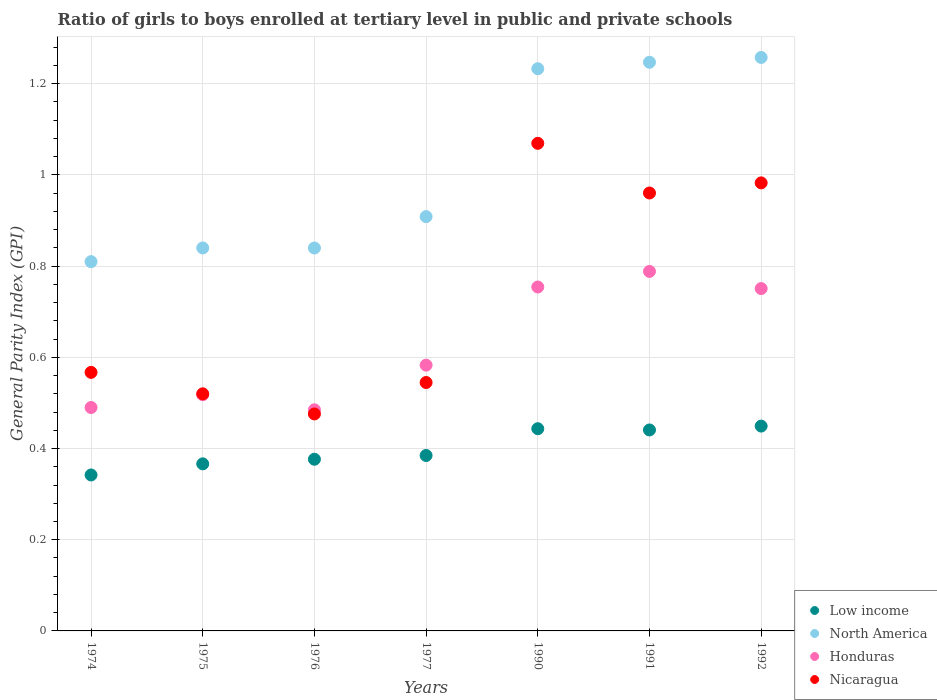How many different coloured dotlines are there?
Make the answer very short. 4. What is the general parity index in Honduras in 1974?
Provide a short and direct response. 0.49. Across all years, what is the maximum general parity index in Honduras?
Provide a succinct answer. 0.79. Across all years, what is the minimum general parity index in Low income?
Keep it short and to the point. 0.34. In which year was the general parity index in Low income minimum?
Your answer should be very brief. 1974. What is the total general parity index in North America in the graph?
Make the answer very short. 7.14. What is the difference between the general parity index in North America in 1974 and that in 1977?
Offer a very short reply. -0.1. What is the difference between the general parity index in Honduras in 1975 and the general parity index in Low income in 1990?
Ensure brevity in your answer.  0.07. What is the average general parity index in North America per year?
Keep it short and to the point. 1.02. In the year 1974, what is the difference between the general parity index in Low income and general parity index in Honduras?
Offer a very short reply. -0.15. In how many years, is the general parity index in Low income greater than 0.88?
Your answer should be very brief. 0. What is the ratio of the general parity index in Low income in 1974 to that in 1990?
Your response must be concise. 0.77. What is the difference between the highest and the second highest general parity index in Honduras?
Make the answer very short. 0.03. What is the difference between the highest and the lowest general parity index in North America?
Your answer should be compact. 0.45. Is it the case that in every year, the sum of the general parity index in Honduras and general parity index in Nicaragua  is greater than the sum of general parity index in North America and general parity index in Low income?
Offer a very short reply. No. Does the general parity index in Honduras monotonically increase over the years?
Offer a very short reply. No. Is the general parity index in Honduras strictly less than the general parity index in Low income over the years?
Offer a very short reply. No. Are the values on the major ticks of Y-axis written in scientific E-notation?
Your answer should be compact. No. How many legend labels are there?
Offer a terse response. 4. How are the legend labels stacked?
Your answer should be compact. Vertical. What is the title of the graph?
Make the answer very short. Ratio of girls to boys enrolled at tertiary level in public and private schools. What is the label or title of the Y-axis?
Make the answer very short. General Parity Index (GPI). What is the General Parity Index (GPI) of Low income in 1974?
Provide a succinct answer. 0.34. What is the General Parity Index (GPI) of North America in 1974?
Make the answer very short. 0.81. What is the General Parity Index (GPI) in Honduras in 1974?
Make the answer very short. 0.49. What is the General Parity Index (GPI) in Nicaragua in 1974?
Keep it short and to the point. 0.57. What is the General Parity Index (GPI) in Low income in 1975?
Your response must be concise. 0.37. What is the General Parity Index (GPI) of North America in 1975?
Keep it short and to the point. 0.84. What is the General Parity Index (GPI) in Honduras in 1975?
Your answer should be very brief. 0.52. What is the General Parity Index (GPI) of Nicaragua in 1975?
Provide a succinct answer. 0.52. What is the General Parity Index (GPI) of Low income in 1976?
Your answer should be compact. 0.38. What is the General Parity Index (GPI) in North America in 1976?
Offer a terse response. 0.84. What is the General Parity Index (GPI) in Honduras in 1976?
Ensure brevity in your answer.  0.48. What is the General Parity Index (GPI) of Nicaragua in 1976?
Provide a short and direct response. 0.48. What is the General Parity Index (GPI) of Low income in 1977?
Give a very brief answer. 0.38. What is the General Parity Index (GPI) of North America in 1977?
Provide a succinct answer. 0.91. What is the General Parity Index (GPI) of Honduras in 1977?
Your response must be concise. 0.58. What is the General Parity Index (GPI) of Nicaragua in 1977?
Ensure brevity in your answer.  0.54. What is the General Parity Index (GPI) in Low income in 1990?
Make the answer very short. 0.44. What is the General Parity Index (GPI) in North America in 1990?
Your answer should be compact. 1.23. What is the General Parity Index (GPI) of Honduras in 1990?
Your answer should be compact. 0.75. What is the General Parity Index (GPI) in Nicaragua in 1990?
Your response must be concise. 1.07. What is the General Parity Index (GPI) of Low income in 1991?
Keep it short and to the point. 0.44. What is the General Parity Index (GPI) of North America in 1991?
Ensure brevity in your answer.  1.25. What is the General Parity Index (GPI) of Honduras in 1991?
Your answer should be compact. 0.79. What is the General Parity Index (GPI) in Nicaragua in 1991?
Provide a short and direct response. 0.96. What is the General Parity Index (GPI) of Low income in 1992?
Provide a succinct answer. 0.45. What is the General Parity Index (GPI) of North America in 1992?
Keep it short and to the point. 1.26. What is the General Parity Index (GPI) in Honduras in 1992?
Your answer should be compact. 0.75. What is the General Parity Index (GPI) of Nicaragua in 1992?
Ensure brevity in your answer.  0.98. Across all years, what is the maximum General Parity Index (GPI) in Low income?
Your response must be concise. 0.45. Across all years, what is the maximum General Parity Index (GPI) of North America?
Keep it short and to the point. 1.26. Across all years, what is the maximum General Parity Index (GPI) in Honduras?
Give a very brief answer. 0.79. Across all years, what is the maximum General Parity Index (GPI) in Nicaragua?
Keep it short and to the point. 1.07. Across all years, what is the minimum General Parity Index (GPI) in Low income?
Make the answer very short. 0.34. Across all years, what is the minimum General Parity Index (GPI) of North America?
Your response must be concise. 0.81. Across all years, what is the minimum General Parity Index (GPI) in Honduras?
Offer a terse response. 0.48. Across all years, what is the minimum General Parity Index (GPI) in Nicaragua?
Give a very brief answer. 0.48. What is the total General Parity Index (GPI) in Low income in the graph?
Provide a succinct answer. 2.8. What is the total General Parity Index (GPI) of North America in the graph?
Offer a terse response. 7.14. What is the total General Parity Index (GPI) in Honduras in the graph?
Your response must be concise. 4.37. What is the total General Parity Index (GPI) of Nicaragua in the graph?
Give a very brief answer. 5.12. What is the difference between the General Parity Index (GPI) of Low income in 1974 and that in 1975?
Offer a very short reply. -0.02. What is the difference between the General Parity Index (GPI) of North America in 1974 and that in 1975?
Make the answer very short. -0.03. What is the difference between the General Parity Index (GPI) in Honduras in 1974 and that in 1975?
Your response must be concise. -0.03. What is the difference between the General Parity Index (GPI) in Nicaragua in 1974 and that in 1975?
Offer a very short reply. 0.05. What is the difference between the General Parity Index (GPI) of Low income in 1974 and that in 1976?
Provide a short and direct response. -0.03. What is the difference between the General Parity Index (GPI) in North America in 1974 and that in 1976?
Offer a terse response. -0.03. What is the difference between the General Parity Index (GPI) of Honduras in 1974 and that in 1976?
Keep it short and to the point. 0.01. What is the difference between the General Parity Index (GPI) of Nicaragua in 1974 and that in 1976?
Offer a terse response. 0.09. What is the difference between the General Parity Index (GPI) of Low income in 1974 and that in 1977?
Give a very brief answer. -0.04. What is the difference between the General Parity Index (GPI) in North America in 1974 and that in 1977?
Provide a short and direct response. -0.1. What is the difference between the General Parity Index (GPI) of Honduras in 1974 and that in 1977?
Your response must be concise. -0.09. What is the difference between the General Parity Index (GPI) of Nicaragua in 1974 and that in 1977?
Your response must be concise. 0.02. What is the difference between the General Parity Index (GPI) in Low income in 1974 and that in 1990?
Offer a very short reply. -0.1. What is the difference between the General Parity Index (GPI) in North America in 1974 and that in 1990?
Make the answer very short. -0.42. What is the difference between the General Parity Index (GPI) of Honduras in 1974 and that in 1990?
Your answer should be very brief. -0.26. What is the difference between the General Parity Index (GPI) of Nicaragua in 1974 and that in 1990?
Offer a very short reply. -0.5. What is the difference between the General Parity Index (GPI) in Low income in 1974 and that in 1991?
Your answer should be compact. -0.1. What is the difference between the General Parity Index (GPI) in North America in 1974 and that in 1991?
Your response must be concise. -0.44. What is the difference between the General Parity Index (GPI) in Honduras in 1974 and that in 1991?
Your answer should be very brief. -0.3. What is the difference between the General Parity Index (GPI) in Nicaragua in 1974 and that in 1991?
Your answer should be very brief. -0.39. What is the difference between the General Parity Index (GPI) of Low income in 1974 and that in 1992?
Your answer should be compact. -0.11. What is the difference between the General Parity Index (GPI) of North America in 1974 and that in 1992?
Your response must be concise. -0.45. What is the difference between the General Parity Index (GPI) in Honduras in 1974 and that in 1992?
Offer a terse response. -0.26. What is the difference between the General Parity Index (GPI) of Nicaragua in 1974 and that in 1992?
Your response must be concise. -0.42. What is the difference between the General Parity Index (GPI) of Low income in 1975 and that in 1976?
Your response must be concise. -0.01. What is the difference between the General Parity Index (GPI) of Honduras in 1975 and that in 1976?
Keep it short and to the point. 0.03. What is the difference between the General Parity Index (GPI) of Nicaragua in 1975 and that in 1976?
Offer a very short reply. 0.04. What is the difference between the General Parity Index (GPI) of Low income in 1975 and that in 1977?
Your answer should be very brief. -0.02. What is the difference between the General Parity Index (GPI) of North America in 1975 and that in 1977?
Your answer should be compact. -0.07. What is the difference between the General Parity Index (GPI) of Honduras in 1975 and that in 1977?
Offer a terse response. -0.06. What is the difference between the General Parity Index (GPI) of Nicaragua in 1975 and that in 1977?
Provide a short and direct response. -0.02. What is the difference between the General Parity Index (GPI) of Low income in 1975 and that in 1990?
Provide a short and direct response. -0.08. What is the difference between the General Parity Index (GPI) in North America in 1975 and that in 1990?
Make the answer very short. -0.39. What is the difference between the General Parity Index (GPI) in Honduras in 1975 and that in 1990?
Keep it short and to the point. -0.24. What is the difference between the General Parity Index (GPI) of Nicaragua in 1975 and that in 1990?
Offer a very short reply. -0.55. What is the difference between the General Parity Index (GPI) of Low income in 1975 and that in 1991?
Give a very brief answer. -0.07. What is the difference between the General Parity Index (GPI) in North America in 1975 and that in 1991?
Your response must be concise. -0.41. What is the difference between the General Parity Index (GPI) in Honduras in 1975 and that in 1991?
Give a very brief answer. -0.27. What is the difference between the General Parity Index (GPI) of Nicaragua in 1975 and that in 1991?
Provide a succinct answer. -0.44. What is the difference between the General Parity Index (GPI) in Low income in 1975 and that in 1992?
Your response must be concise. -0.08. What is the difference between the General Parity Index (GPI) in North America in 1975 and that in 1992?
Offer a terse response. -0.42. What is the difference between the General Parity Index (GPI) in Honduras in 1975 and that in 1992?
Provide a short and direct response. -0.23. What is the difference between the General Parity Index (GPI) of Nicaragua in 1975 and that in 1992?
Give a very brief answer. -0.46. What is the difference between the General Parity Index (GPI) of Low income in 1976 and that in 1977?
Keep it short and to the point. -0.01. What is the difference between the General Parity Index (GPI) of North America in 1976 and that in 1977?
Keep it short and to the point. -0.07. What is the difference between the General Parity Index (GPI) of Honduras in 1976 and that in 1977?
Make the answer very short. -0.1. What is the difference between the General Parity Index (GPI) of Nicaragua in 1976 and that in 1977?
Offer a terse response. -0.07. What is the difference between the General Parity Index (GPI) in Low income in 1976 and that in 1990?
Make the answer very short. -0.07. What is the difference between the General Parity Index (GPI) in North America in 1976 and that in 1990?
Ensure brevity in your answer.  -0.39. What is the difference between the General Parity Index (GPI) in Honduras in 1976 and that in 1990?
Offer a very short reply. -0.27. What is the difference between the General Parity Index (GPI) in Nicaragua in 1976 and that in 1990?
Offer a terse response. -0.59. What is the difference between the General Parity Index (GPI) in Low income in 1976 and that in 1991?
Ensure brevity in your answer.  -0.06. What is the difference between the General Parity Index (GPI) of North America in 1976 and that in 1991?
Make the answer very short. -0.41. What is the difference between the General Parity Index (GPI) in Honduras in 1976 and that in 1991?
Offer a very short reply. -0.3. What is the difference between the General Parity Index (GPI) of Nicaragua in 1976 and that in 1991?
Ensure brevity in your answer.  -0.48. What is the difference between the General Parity Index (GPI) in Low income in 1976 and that in 1992?
Keep it short and to the point. -0.07. What is the difference between the General Parity Index (GPI) in North America in 1976 and that in 1992?
Offer a very short reply. -0.42. What is the difference between the General Parity Index (GPI) in Honduras in 1976 and that in 1992?
Give a very brief answer. -0.27. What is the difference between the General Parity Index (GPI) in Nicaragua in 1976 and that in 1992?
Your answer should be compact. -0.51. What is the difference between the General Parity Index (GPI) of Low income in 1977 and that in 1990?
Offer a very short reply. -0.06. What is the difference between the General Parity Index (GPI) of North America in 1977 and that in 1990?
Your response must be concise. -0.32. What is the difference between the General Parity Index (GPI) in Honduras in 1977 and that in 1990?
Your response must be concise. -0.17. What is the difference between the General Parity Index (GPI) of Nicaragua in 1977 and that in 1990?
Keep it short and to the point. -0.52. What is the difference between the General Parity Index (GPI) of Low income in 1977 and that in 1991?
Your answer should be very brief. -0.06. What is the difference between the General Parity Index (GPI) of North America in 1977 and that in 1991?
Your answer should be compact. -0.34. What is the difference between the General Parity Index (GPI) of Honduras in 1977 and that in 1991?
Keep it short and to the point. -0.21. What is the difference between the General Parity Index (GPI) in Nicaragua in 1977 and that in 1991?
Keep it short and to the point. -0.42. What is the difference between the General Parity Index (GPI) in Low income in 1977 and that in 1992?
Ensure brevity in your answer.  -0.06. What is the difference between the General Parity Index (GPI) in North America in 1977 and that in 1992?
Make the answer very short. -0.35. What is the difference between the General Parity Index (GPI) in Honduras in 1977 and that in 1992?
Ensure brevity in your answer.  -0.17. What is the difference between the General Parity Index (GPI) of Nicaragua in 1977 and that in 1992?
Ensure brevity in your answer.  -0.44. What is the difference between the General Parity Index (GPI) in Low income in 1990 and that in 1991?
Ensure brevity in your answer.  0. What is the difference between the General Parity Index (GPI) of North America in 1990 and that in 1991?
Offer a very short reply. -0.01. What is the difference between the General Parity Index (GPI) of Honduras in 1990 and that in 1991?
Your response must be concise. -0.03. What is the difference between the General Parity Index (GPI) in Nicaragua in 1990 and that in 1991?
Ensure brevity in your answer.  0.11. What is the difference between the General Parity Index (GPI) of Low income in 1990 and that in 1992?
Your answer should be compact. -0.01. What is the difference between the General Parity Index (GPI) in North America in 1990 and that in 1992?
Your answer should be compact. -0.02. What is the difference between the General Parity Index (GPI) of Honduras in 1990 and that in 1992?
Your answer should be compact. 0. What is the difference between the General Parity Index (GPI) in Nicaragua in 1990 and that in 1992?
Give a very brief answer. 0.09. What is the difference between the General Parity Index (GPI) in Low income in 1991 and that in 1992?
Your answer should be very brief. -0.01. What is the difference between the General Parity Index (GPI) in North America in 1991 and that in 1992?
Keep it short and to the point. -0.01. What is the difference between the General Parity Index (GPI) of Honduras in 1991 and that in 1992?
Offer a very short reply. 0.04. What is the difference between the General Parity Index (GPI) in Nicaragua in 1991 and that in 1992?
Your answer should be compact. -0.02. What is the difference between the General Parity Index (GPI) in Low income in 1974 and the General Parity Index (GPI) in North America in 1975?
Your answer should be very brief. -0.5. What is the difference between the General Parity Index (GPI) in Low income in 1974 and the General Parity Index (GPI) in Honduras in 1975?
Your answer should be compact. -0.18. What is the difference between the General Parity Index (GPI) in Low income in 1974 and the General Parity Index (GPI) in Nicaragua in 1975?
Offer a terse response. -0.18. What is the difference between the General Parity Index (GPI) in North America in 1974 and the General Parity Index (GPI) in Honduras in 1975?
Provide a short and direct response. 0.29. What is the difference between the General Parity Index (GPI) of North America in 1974 and the General Parity Index (GPI) of Nicaragua in 1975?
Your response must be concise. 0.29. What is the difference between the General Parity Index (GPI) in Honduras in 1974 and the General Parity Index (GPI) in Nicaragua in 1975?
Provide a short and direct response. -0.03. What is the difference between the General Parity Index (GPI) in Low income in 1974 and the General Parity Index (GPI) in North America in 1976?
Offer a very short reply. -0.5. What is the difference between the General Parity Index (GPI) of Low income in 1974 and the General Parity Index (GPI) of Honduras in 1976?
Provide a succinct answer. -0.14. What is the difference between the General Parity Index (GPI) in Low income in 1974 and the General Parity Index (GPI) in Nicaragua in 1976?
Give a very brief answer. -0.13. What is the difference between the General Parity Index (GPI) of North America in 1974 and the General Parity Index (GPI) of Honduras in 1976?
Offer a terse response. 0.32. What is the difference between the General Parity Index (GPI) of North America in 1974 and the General Parity Index (GPI) of Nicaragua in 1976?
Keep it short and to the point. 0.33. What is the difference between the General Parity Index (GPI) in Honduras in 1974 and the General Parity Index (GPI) in Nicaragua in 1976?
Provide a short and direct response. 0.01. What is the difference between the General Parity Index (GPI) in Low income in 1974 and the General Parity Index (GPI) in North America in 1977?
Make the answer very short. -0.57. What is the difference between the General Parity Index (GPI) of Low income in 1974 and the General Parity Index (GPI) of Honduras in 1977?
Provide a short and direct response. -0.24. What is the difference between the General Parity Index (GPI) in Low income in 1974 and the General Parity Index (GPI) in Nicaragua in 1977?
Your answer should be very brief. -0.2. What is the difference between the General Parity Index (GPI) of North America in 1974 and the General Parity Index (GPI) of Honduras in 1977?
Keep it short and to the point. 0.23. What is the difference between the General Parity Index (GPI) in North America in 1974 and the General Parity Index (GPI) in Nicaragua in 1977?
Ensure brevity in your answer.  0.27. What is the difference between the General Parity Index (GPI) of Honduras in 1974 and the General Parity Index (GPI) of Nicaragua in 1977?
Ensure brevity in your answer.  -0.05. What is the difference between the General Parity Index (GPI) in Low income in 1974 and the General Parity Index (GPI) in North America in 1990?
Provide a short and direct response. -0.89. What is the difference between the General Parity Index (GPI) of Low income in 1974 and the General Parity Index (GPI) of Honduras in 1990?
Provide a succinct answer. -0.41. What is the difference between the General Parity Index (GPI) in Low income in 1974 and the General Parity Index (GPI) in Nicaragua in 1990?
Make the answer very short. -0.73. What is the difference between the General Parity Index (GPI) of North America in 1974 and the General Parity Index (GPI) of Honduras in 1990?
Keep it short and to the point. 0.06. What is the difference between the General Parity Index (GPI) in North America in 1974 and the General Parity Index (GPI) in Nicaragua in 1990?
Make the answer very short. -0.26. What is the difference between the General Parity Index (GPI) in Honduras in 1974 and the General Parity Index (GPI) in Nicaragua in 1990?
Offer a very short reply. -0.58. What is the difference between the General Parity Index (GPI) of Low income in 1974 and the General Parity Index (GPI) of North America in 1991?
Provide a succinct answer. -0.91. What is the difference between the General Parity Index (GPI) in Low income in 1974 and the General Parity Index (GPI) in Honduras in 1991?
Your answer should be very brief. -0.45. What is the difference between the General Parity Index (GPI) in Low income in 1974 and the General Parity Index (GPI) in Nicaragua in 1991?
Your answer should be very brief. -0.62. What is the difference between the General Parity Index (GPI) in North America in 1974 and the General Parity Index (GPI) in Honduras in 1991?
Provide a short and direct response. 0.02. What is the difference between the General Parity Index (GPI) of North America in 1974 and the General Parity Index (GPI) of Nicaragua in 1991?
Offer a very short reply. -0.15. What is the difference between the General Parity Index (GPI) of Honduras in 1974 and the General Parity Index (GPI) of Nicaragua in 1991?
Offer a terse response. -0.47. What is the difference between the General Parity Index (GPI) of Low income in 1974 and the General Parity Index (GPI) of North America in 1992?
Give a very brief answer. -0.92. What is the difference between the General Parity Index (GPI) in Low income in 1974 and the General Parity Index (GPI) in Honduras in 1992?
Offer a terse response. -0.41. What is the difference between the General Parity Index (GPI) of Low income in 1974 and the General Parity Index (GPI) of Nicaragua in 1992?
Provide a short and direct response. -0.64. What is the difference between the General Parity Index (GPI) of North America in 1974 and the General Parity Index (GPI) of Honduras in 1992?
Your response must be concise. 0.06. What is the difference between the General Parity Index (GPI) of North America in 1974 and the General Parity Index (GPI) of Nicaragua in 1992?
Ensure brevity in your answer.  -0.17. What is the difference between the General Parity Index (GPI) of Honduras in 1974 and the General Parity Index (GPI) of Nicaragua in 1992?
Your answer should be compact. -0.49. What is the difference between the General Parity Index (GPI) of Low income in 1975 and the General Parity Index (GPI) of North America in 1976?
Your response must be concise. -0.47. What is the difference between the General Parity Index (GPI) of Low income in 1975 and the General Parity Index (GPI) of Honduras in 1976?
Offer a very short reply. -0.12. What is the difference between the General Parity Index (GPI) of Low income in 1975 and the General Parity Index (GPI) of Nicaragua in 1976?
Your answer should be compact. -0.11. What is the difference between the General Parity Index (GPI) in North America in 1975 and the General Parity Index (GPI) in Honduras in 1976?
Keep it short and to the point. 0.35. What is the difference between the General Parity Index (GPI) of North America in 1975 and the General Parity Index (GPI) of Nicaragua in 1976?
Give a very brief answer. 0.36. What is the difference between the General Parity Index (GPI) of Honduras in 1975 and the General Parity Index (GPI) of Nicaragua in 1976?
Your answer should be compact. 0.04. What is the difference between the General Parity Index (GPI) of Low income in 1975 and the General Parity Index (GPI) of North America in 1977?
Your answer should be compact. -0.54. What is the difference between the General Parity Index (GPI) in Low income in 1975 and the General Parity Index (GPI) in Honduras in 1977?
Offer a very short reply. -0.22. What is the difference between the General Parity Index (GPI) in Low income in 1975 and the General Parity Index (GPI) in Nicaragua in 1977?
Provide a succinct answer. -0.18. What is the difference between the General Parity Index (GPI) in North America in 1975 and the General Parity Index (GPI) in Honduras in 1977?
Give a very brief answer. 0.26. What is the difference between the General Parity Index (GPI) of North America in 1975 and the General Parity Index (GPI) of Nicaragua in 1977?
Make the answer very short. 0.3. What is the difference between the General Parity Index (GPI) in Honduras in 1975 and the General Parity Index (GPI) in Nicaragua in 1977?
Offer a terse response. -0.03. What is the difference between the General Parity Index (GPI) in Low income in 1975 and the General Parity Index (GPI) in North America in 1990?
Make the answer very short. -0.87. What is the difference between the General Parity Index (GPI) in Low income in 1975 and the General Parity Index (GPI) in Honduras in 1990?
Make the answer very short. -0.39. What is the difference between the General Parity Index (GPI) in Low income in 1975 and the General Parity Index (GPI) in Nicaragua in 1990?
Give a very brief answer. -0.7. What is the difference between the General Parity Index (GPI) in North America in 1975 and the General Parity Index (GPI) in Honduras in 1990?
Offer a very short reply. 0.09. What is the difference between the General Parity Index (GPI) in North America in 1975 and the General Parity Index (GPI) in Nicaragua in 1990?
Ensure brevity in your answer.  -0.23. What is the difference between the General Parity Index (GPI) in Honduras in 1975 and the General Parity Index (GPI) in Nicaragua in 1990?
Your response must be concise. -0.55. What is the difference between the General Parity Index (GPI) of Low income in 1975 and the General Parity Index (GPI) of North America in 1991?
Your response must be concise. -0.88. What is the difference between the General Parity Index (GPI) of Low income in 1975 and the General Parity Index (GPI) of Honduras in 1991?
Offer a terse response. -0.42. What is the difference between the General Parity Index (GPI) in Low income in 1975 and the General Parity Index (GPI) in Nicaragua in 1991?
Offer a terse response. -0.59. What is the difference between the General Parity Index (GPI) in North America in 1975 and the General Parity Index (GPI) in Honduras in 1991?
Offer a very short reply. 0.05. What is the difference between the General Parity Index (GPI) of North America in 1975 and the General Parity Index (GPI) of Nicaragua in 1991?
Offer a terse response. -0.12. What is the difference between the General Parity Index (GPI) in Honduras in 1975 and the General Parity Index (GPI) in Nicaragua in 1991?
Offer a terse response. -0.44. What is the difference between the General Parity Index (GPI) of Low income in 1975 and the General Parity Index (GPI) of North America in 1992?
Give a very brief answer. -0.89. What is the difference between the General Parity Index (GPI) of Low income in 1975 and the General Parity Index (GPI) of Honduras in 1992?
Provide a short and direct response. -0.38. What is the difference between the General Parity Index (GPI) in Low income in 1975 and the General Parity Index (GPI) in Nicaragua in 1992?
Your response must be concise. -0.62. What is the difference between the General Parity Index (GPI) in North America in 1975 and the General Parity Index (GPI) in Honduras in 1992?
Keep it short and to the point. 0.09. What is the difference between the General Parity Index (GPI) of North America in 1975 and the General Parity Index (GPI) of Nicaragua in 1992?
Ensure brevity in your answer.  -0.14. What is the difference between the General Parity Index (GPI) of Honduras in 1975 and the General Parity Index (GPI) of Nicaragua in 1992?
Your answer should be very brief. -0.46. What is the difference between the General Parity Index (GPI) in Low income in 1976 and the General Parity Index (GPI) in North America in 1977?
Offer a terse response. -0.53. What is the difference between the General Parity Index (GPI) of Low income in 1976 and the General Parity Index (GPI) of Honduras in 1977?
Make the answer very short. -0.21. What is the difference between the General Parity Index (GPI) in Low income in 1976 and the General Parity Index (GPI) in Nicaragua in 1977?
Offer a terse response. -0.17. What is the difference between the General Parity Index (GPI) in North America in 1976 and the General Parity Index (GPI) in Honduras in 1977?
Provide a succinct answer. 0.26. What is the difference between the General Parity Index (GPI) in North America in 1976 and the General Parity Index (GPI) in Nicaragua in 1977?
Keep it short and to the point. 0.29. What is the difference between the General Parity Index (GPI) in Honduras in 1976 and the General Parity Index (GPI) in Nicaragua in 1977?
Keep it short and to the point. -0.06. What is the difference between the General Parity Index (GPI) in Low income in 1976 and the General Parity Index (GPI) in North America in 1990?
Ensure brevity in your answer.  -0.86. What is the difference between the General Parity Index (GPI) in Low income in 1976 and the General Parity Index (GPI) in Honduras in 1990?
Your answer should be very brief. -0.38. What is the difference between the General Parity Index (GPI) of Low income in 1976 and the General Parity Index (GPI) of Nicaragua in 1990?
Your answer should be compact. -0.69. What is the difference between the General Parity Index (GPI) in North America in 1976 and the General Parity Index (GPI) in Honduras in 1990?
Keep it short and to the point. 0.09. What is the difference between the General Parity Index (GPI) of North America in 1976 and the General Parity Index (GPI) of Nicaragua in 1990?
Offer a very short reply. -0.23. What is the difference between the General Parity Index (GPI) of Honduras in 1976 and the General Parity Index (GPI) of Nicaragua in 1990?
Ensure brevity in your answer.  -0.58. What is the difference between the General Parity Index (GPI) of Low income in 1976 and the General Parity Index (GPI) of North America in 1991?
Provide a succinct answer. -0.87. What is the difference between the General Parity Index (GPI) of Low income in 1976 and the General Parity Index (GPI) of Honduras in 1991?
Provide a short and direct response. -0.41. What is the difference between the General Parity Index (GPI) of Low income in 1976 and the General Parity Index (GPI) of Nicaragua in 1991?
Provide a short and direct response. -0.58. What is the difference between the General Parity Index (GPI) in North America in 1976 and the General Parity Index (GPI) in Honduras in 1991?
Make the answer very short. 0.05. What is the difference between the General Parity Index (GPI) in North America in 1976 and the General Parity Index (GPI) in Nicaragua in 1991?
Ensure brevity in your answer.  -0.12. What is the difference between the General Parity Index (GPI) in Honduras in 1976 and the General Parity Index (GPI) in Nicaragua in 1991?
Make the answer very short. -0.48. What is the difference between the General Parity Index (GPI) of Low income in 1976 and the General Parity Index (GPI) of North America in 1992?
Keep it short and to the point. -0.88. What is the difference between the General Parity Index (GPI) of Low income in 1976 and the General Parity Index (GPI) of Honduras in 1992?
Make the answer very short. -0.37. What is the difference between the General Parity Index (GPI) of Low income in 1976 and the General Parity Index (GPI) of Nicaragua in 1992?
Ensure brevity in your answer.  -0.61. What is the difference between the General Parity Index (GPI) in North America in 1976 and the General Parity Index (GPI) in Honduras in 1992?
Offer a very short reply. 0.09. What is the difference between the General Parity Index (GPI) of North America in 1976 and the General Parity Index (GPI) of Nicaragua in 1992?
Your answer should be compact. -0.14. What is the difference between the General Parity Index (GPI) in Honduras in 1976 and the General Parity Index (GPI) in Nicaragua in 1992?
Provide a succinct answer. -0.5. What is the difference between the General Parity Index (GPI) in Low income in 1977 and the General Parity Index (GPI) in North America in 1990?
Ensure brevity in your answer.  -0.85. What is the difference between the General Parity Index (GPI) of Low income in 1977 and the General Parity Index (GPI) of Honduras in 1990?
Ensure brevity in your answer.  -0.37. What is the difference between the General Parity Index (GPI) in Low income in 1977 and the General Parity Index (GPI) in Nicaragua in 1990?
Offer a very short reply. -0.68. What is the difference between the General Parity Index (GPI) of North America in 1977 and the General Parity Index (GPI) of Honduras in 1990?
Offer a very short reply. 0.15. What is the difference between the General Parity Index (GPI) of North America in 1977 and the General Parity Index (GPI) of Nicaragua in 1990?
Keep it short and to the point. -0.16. What is the difference between the General Parity Index (GPI) of Honduras in 1977 and the General Parity Index (GPI) of Nicaragua in 1990?
Give a very brief answer. -0.49. What is the difference between the General Parity Index (GPI) in Low income in 1977 and the General Parity Index (GPI) in North America in 1991?
Offer a terse response. -0.86. What is the difference between the General Parity Index (GPI) of Low income in 1977 and the General Parity Index (GPI) of Honduras in 1991?
Offer a very short reply. -0.4. What is the difference between the General Parity Index (GPI) of Low income in 1977 and the General Parity Index (GPI) of Nicaragua in 1991?
Provide a succinct answer. -0.58. What is the difference between the General Parity Index (GPI) in North America in 1977 and the General Parity Index (GPI) in Honduras in 1991?
Keep it short and to the point. 0.12. What is the difference between the General Parity Index (GPI) of North America in 1977 and the General Parity Index (GPI) of Nicaragua in 1991?
Provide a succinct answer. -0.05. What is the difference between the General Parity Index (GPI) of Honduras in 1977 and the General Parity Index (GPI) of Nicaragua in 1991?
Your answer should be very brief. -0.38. What is the difference between the General Parity Index (GPI) in Low income in 1977 and the General Parity Index (GPI) in North America in 1992?
Offer a very short reply. -0.87. What is the difference between the General Parity Index (GPI) of Low income in 1977 and the General Parity Index (GPI) of Honduras in 1992?
Ensure brevity in your answer.  -0.37. What is the difference between the General Parity Index (GPI) of Low income in 1977 and the General Parity Index (GPI) of Nicaragua in 1992?
Your answer should be very brief. -0.6. What is the difference between the General Parity Index (GPI) of North America in 1977 and the General Parity Index (GPI) of Honduras in 1992?
Your response must be concise. 0.16. What is the difference between the General Parity Index (GPI) in North America in 1977 and the General Parity Index (GPI) in Nicaragua in 1992?
Give a very brief answer. -0.07. What is the difference between the General Parity Index (GPI) of Honduras in 1977 and the General Parity Index (GPI) of Nicaragua in 1992?
Provide a short and direct response. -0.4. What is the difference between the General Parity Index (GPI) of Low income in 1990 and the General Parity Index (GPI) of North America in 1991?
Your answer should be compact. -0.8. What is the difference between the General Parity Index (GPI) of Low income in 1990 and the General Parity Index (GPI) of Honduras in 1991?
Your answer should be very brief. -0.34. What is the difference between the General Parity Index (GPI) of Low income in 1990 and the General Parity Index (GPI) of Nicaragua in 1991?
Provide a short and direct response. -0.52. What is the difference between the General Parity Index (GPI) of North America in 1990 and the General Parity Index (GPI) of Honduras in 1991?
Provide a short and direct response. 0.44. What is the difference between the General Parity Index (GPI) of North America in 1990 and the General Parity Index (GPI) of Nicaragua in 1991?
Give a very brief answer. 0.27. What is the difference between the General Parity Index (GPI) of Honduras in 1990 and the General Parity Index (GPI) of Nicaragua in 1991?
Keep it short and to the point. -0.21. What is the difference between the General Parity Index (GPI) in Low income in 1990 and the General Parity Index (GPI) in North America in 1992?
Give a very brief answer. -0.81. What is the difference between the General Parity Index (GPI) of Low income in 1990 and the General Parity Index (GPI) of Honduras in 1992?
Ensure brevity in your answer.  -0.31. What is the difference between the General Parity Index (GPI) of Low income in 1990 and the General Parity Index (GPI) of Nicaragua in 1992?
Keep it short and to the point. -0.54. What is the difference between the General Parity Index (GPI) in North America in 1990 and the General Parity Index (GPI) in Honduras in 1992?
Provide a succinct answer. 0.48. What is the difference between the General Parity Index (GPI) of North America in 1990 and the General Parity Index (GPI) of Nicaragua in 1992?
Your answer should be compact. 0.25. What is the difference between the General Parity Index (GPI) of Honduras in 1990 and the General Parity Index (GPI) of Nicaragua in 1992?
Your answer should be very brief. -0.23. What is the difference between the General Parity Index (GPI) in Low income in 1991 and the General Parity Index (GPI) in North America in 1992?
Make the answer very short. -0.82. What is the difference between the General Parity Index (GPI) of Low income in 1991 and the General Parity Index (GPI) of Honduras in 1992?
Provide a succinct answer. -0.31. What is the difference between the General Parity Index (GPI) of Low income in 1991 and the General Parity Index (GPI) of Nicaragua in 1992?
Your response must be concise. -0.54. What is the difference between the General Parity Index (GPI) of North America in 1991 and the General Parity Index (GPI) of Honduras in 1992?
Ensure brevity in your answer.  0.5. What is the difference between the General Parity Index (GPI) in North America in 1991 and the General Parity Index (GPI) in Nicaragua in 1992?
Make the answer very short. 0.26. What is the difference between the General Parity Index (GPI) of Honduras in 1991 and the General Parity Index (GPI) of Nicaragua in 1992?
Make the answer very short. -0.19. What is the average General Parity Index (GPI) in Low income per year?
Provide a succinct answer. 0.4. What is the average General Parity Index (GPI) of North America per year?
Ensure brevity in your answer.  1.02. What is the average General Parity Index (GPI) in Honduras per year?
Your response must be concise. 0.62. What is the average General Parity Index (GPI) in Nicaragua per year?
Provide a short and direct response. 0.73. In the year 1974, what is the difference between the General Parity Index (GPI) in Low income and General Parity Index (GPI) in North America?
Offer a terse response. -0.47. In the year 1974, what is the difference between the General Parity Index (GPI) of Low income and General Parity Index (GPI) of Honduras?
Keep it short and to the point. -0.15. In the year 1974, what is the difference between the General Parity Index (GPI) of Low income and General Parity Index (GPI) of Nicaragua?
Make the answer very short. -0.23. In the year 1974, what is the difference between the General Parity Index (GPI) in North America and General Parity Index (GPI) in Honduras?
Keep it short and to the point. 0.32. In the year 1974, what is the difference between the General Parity Index (GPI) of North America and General Parity Index (GPI) of Nicaragua?
Provide a short and direct response. 0.24. In the year 1974, what is the difference between the General Parity Index (GPI) in Honduras and General Parity Index (GPI) in Nicaragua?
Provide a succinct answer. -0.08. In the year 1975, what is the difference between the General Parity Index (GPI) in Low income and General Parity Index (GPI) in North America?
Provide a succinct answer. -0.47. In the year 1975, what is the difference between the General Parity Index (GPI) in Low income and General Parity Index (GPI) in Honduras?
Provide a succinct answer. -0.15. In the year 1975, what is the difference between the General Parity Index (GPI) of Low income and General Parity Index (GPI) of Nicaragua?
Keep it short and to the point. -0.15. In the year 1975, what is the difference between the General Parity Index (GPI) in North America and General Parity Index (GPI) in Honduras?
Your answer should be compact. 0.32. In the year 1975, what is the difference between the General Parity Index (GPI) of North America and General Parity Index (GPI) of Nicaragua?
Ensure brevity in your answer.  0.32. In the year 1975, what is the difference between the General Parity Index (GPI) in Honduras and General Parity Index (GPI) in Nicaragua?
Offer a very short reply. -0. In the year 1976, what is the difference between the General Parity Index (GPI) of Low income and General Parity Index (GPI) of North America?
Your answer should be very brief. -0.46. In the year 1976, what is the difference between the General Parity Index (GPI) of Low income and General Parity Index (GPI) of Honduras?
Keep it short and to the point. -0.11. In the year 1976, what is the difference between the General Parity Index (GPI) of Low income and General Parity Index (GPI) of Nicaragua?
Provide a succinct answer. -0.1. In the year 1976, what is the difference between the General Parity Index (GPI) in North America and General Parity Index (GPI) in Honduras?
Provide a short and direct response. 0.35. In the year 1976, what is the difference between the General Parity Index (GPI) in North America and General Parity Index (GPI) in Nicaragua?
Your response must be concise. 0.36. In the year 1976, what is the difference between the General Parity Index (GPI) of Honduras and General Parity Index (GPI) of Nicaragua?
Offer a very short reply. 0.01. In the year 1977, what is the difference between the General Parity Index (GPI) of Low income and General Parity Index (GPI) of North America?
Offer a very short reply. -0.52. In the year 1977, what is the difference between the General Parity Index (GPI) in Low income and General Parity Index (GPI) in Honduras?
Make the answer very short. -0.2. In the year 1977, what is the difference between the General Parity Index (GPI) in Low income and General Parity Index (GPI) in Nicaragua?
Provide a succinct answer. -0.16. In the year 1977, what is the difference between the General Parity Index (GPI) of North America and General Parity Index (GPI) of Honduras?
Your answer should be compact. 0.33. In the year 1977, what is the difference between the General Parity Index (GPI) in North America and General Parity Index (GPI) in Nicaragua?
Give a very brief answer. 0.36. In the year 1977, what is the difference between the General Parity Index (GPI) in Honduras and General Parity Index (GPI) in Nicaragua?
Offer a terse response. 0.04. In the year 1990, what is the difference between the General Parity Index (GPI) in Low income and General Parity Index (GPI) in North America?
Provide a short and direct response. -0.79. In the year 1990, what is the difference between the General Parity Index (GPI) of Low income and General Parity Index (GPI) of Honduras?
Offer a very short reply. -0.31. In the year 1990, what is the difference between the General Parity Index (GPI) of Low income and General Parity Index (GPI) of Nicaragua?
Offer a terse response. -0.63. In the year 1990, what is the difference between the General Parity Index (GPI) of North America and General Parity Index (GPI) of Honduras?
Your response must be concise. 0.48. In the year 1990, what is the difference between the General Parity Index (GPI) in North America and General Parity Index (GPI) in Nicaragua?
Your response must be concise. 0.16. In the year 1990, what is the difference between the General Parity Index (GPI) of Honduras and General Parity Index (GPI) of Nicaragua?
Offer a terse response. -0.32. In the year 1991, what is the difference between the General Parity Index (GPI) of Low income and General Parity Index (GPI) of North America?
Make the answer very short. -0.81. In the year 1991, what is the difference between the General Parity Index (GPI) of Low income and General Parity Index (GPI) of Honduras?
Your answer should be very brief. -0.35. In the year 1991, what is the difference between the General Parity Index (GPI) of Low income and General Parity Index (GPI) of Nicaragua?
Your response must be concise. -0.52. In the year 1991, what is the difference between the General Parity Index (GPI) of North America and General Parity Index (GPI) of Honduras?
Give a very brief answer. 0.46. In the year 1991, what is the difference between the General Parity Index (GPI) of North America and General Parity Index (GPI) of Nicaragua?
Your answer should be compact. 0.29. In the year 1991, what is the difference between the General Parity Index (GPI) of Honduras and General Parity Index (GPI) of Nicaragua?
Provide a short and direct response. -0.17. In the year 1992, what is the difference between the General Parity Index (GPI) in Low income and General Parity Index (GPI) in North America?
Your response must be concise. -0.81. In the year 1992, what is the difference between the General Parity Index (GPI) of Low income and General Parity Index (GPI) of Honduras?
Your response must be concise. -0.3. In the year 1992, what is the difference between the General Parity Index (GPI) in Low income and General Parity Index (GPI) in Nicaragua?
Offer a terse response. -0.53. In the year 1992, what is the difference between the General Parity Index (GPI) in North America and General Parity Index (GPI) in Honduras?
Provide a succinct answer. 0.51. In the year 1992, what is the difference between the General Parity Index (GPI) of North America and General Parity Index (GPI) of Nicaragua?
Keep it short and to the point. 0.28. In the year 1992, what is the difference between the General Parity Index (GPI) in Honduras and General Parity Index (GPI) in Nicaragua?
Provide a short and direct response. -0.23. What is the ratio of the General Parity Index (GPI) in Low income in 1974 to that in 1975?
Your response must be concise. 0.93. What is the ratio of the General Parity Index (GPI) of North America in 1974 to that in 1975?
Provide a succinct answer. 0.96. What is the ratio of the General Parity Index (GPI) of Honduras in 1974 to that in 1975?
Provide a short and direct response. 0.95. What is the ratio of the General Parity Index (GPI) of Nicaragua in 1974 to that in 1975?
Offer a terse response. 1.09. What is the ratio of the General Parity Index (GPI) of Low income in 1974 to that in 1976?
Offer a very short reply. 0.91. What is the ratio of the General Parity Index (GPI) of North America in 1974 to that in 1976?
Your answer should be compact. 0.96. What is the ratio of the General Parity Index (GPI) of Honduras in 1974 to that in 1976?
Give a very brief answer. 1.01. What is the ratio of the General Parity Index (GPI) in Nicaragua in 1974 to that in 1976?
Ensure brevity in your answer.  1.19. What is the ratio of the General Parity Index (GPI) in Low income in 1974 to that in 1977?
Offer a very short reply. 0.89. What is the ratio of the General Parity Index (GPI) of North America in 1974 to that in 1977?
Give a very brief answer. 0.89. What is the ratio of the General Parity Index (GPI) in Honduras in 1974 to that in 1977?
Keep it short and to the point. 0.84. What is the ratio of the General Parity Index (GPI) in Nicaragua in 1974 to that in 1977?
Make the answer very short. 1.04. What is the ratio of the General Parity Index (GPI) of Low income in 1974 to that in 1990?
Make the answer very short. 0.77. What is the ratio of the General Parity Index (GPI) in North America in 1974 to that in 1990?
Make the answer very short. 0.66. What is the ratio of the General Parity Index (GPI) in Honduras in 1974 to that in 1990?
Offer a terse response. 0.65. What is the ratio of the General Parity Index (GPI) of Nicaragua in 1974 to that in 1990?
Give a very brief answer. 0.53. What is the ratio of the General Parity Index (GPI) in Low income in 1974 to that in 1991?
Offer a very short reply. 0.78. What is the ratio of the General Parity Index (GPI) of North America in 1974 to that in 1991?
Your answer should be very brief. 0.65. What is the ratio of the General Parity Index (GPI) in Honduras in 1974 to that in 1991?
Provide a short and direct response. 0.62. What is the ratio of the General Parity Index (GPI) of Nicaragua in 1974 to that in 1991?
Offer a very short reply. 0.59. What is the ratio of the General Parity Index (GPI) in Low income in 1974 to that in 1992?
Your response must be concise. 0.76. What is the ratio of the General Parity Index (GPI) in North America in 1974 to that in 1992?
Your response must be concise. 0.64. What is the ratio of the General Parity Index (GPI) in Honduras in 1974 to that in 1992?
Keep it short and to the point. 0.65. What is the ratio of the General Parity Index (GPI) of Nicaragua in 1974 to that in 1992?
Make the answer very short. 0.58. What is the ratio of the General Parity Index (GPI) of Low income in 1975 to that in 1976?
Your response must be concise. 0.97. What is the ratio of the General Parity Index (GPI) of North America in 1975 to that in 1976?
Offer a very short reply. 1. What is the ratio of the General Parity Index (GPI) of Honduras in 1975 to that in 1976?
Ensure brevity in your answer.  1.07. What is the ratio of the General Parity Index (GPI) in Nicaragua in 1975 to that in 1976?
Your answer should be very brief. 1.09. What is the ratio of the General Parity Index (GPI) in North America in 1975 to that in 1977?
Make the answer very short. 0.92. What is the ratio of the General Parity Index (GPI) of Honduras in 1975 to that in 1977?
Provide a succinct answer. 0.89. What is the ratio of the General Parity Index (GPI) in Nicaragua in 1975 to that in 1977?
Provide a short and direct response. 0.95. What is the ratio of the General Parity Index (GPI) in Low income in 1975 to that in 1990?
Keep it short and to the point. 0.83. What is the ratio of the General Parity Index (GPI) in North America in 1975 to that in 1990?
Keep it short and to the point. 0.68. What is the ratio of the General Parity Index (GPI) in Honduras in 1975 to that in 1990?
Your response must be concise. 0.69. What is the ratio of the General Parity Index (GPI) in Nicaragua in 1975 to that in 1990?
Your answer should be very brief. 0.49. What is the ratio of the General Parity Index (GPI) of Low income in 1975 to that in 1991?
Your answer should be compact. 0.83. What is the ratio of the General Parity Index (GPI) of North America in 1975 to that in 1991?
Ensure brevity in your answer.  0.67. What is the ratio of the General Parity Index (GPI) of Honduras in 1975 to that in 1991?
Keep it short and to the point. 0.66. What is the ratio of the General Parity Index (GPI) of Nicaragua in 1975 to that in 1991?
Offer a terse response. 0.54. What is the ratio of the General Parity Index (GPI) in Low income in 1975 to that in 1992?
Offer a very short reply. 0.82. What is the ratio of the General Parity Index (GPI) of North America in 1975 to that in 1992?
Provide a succinct answer. 0.67. What is the ratio of the General Parity Index (GPI) in Honduras in 1975 to that in 1992?
Keep it short and to the point. 0.69. What is the ratio of the General Parity Index (GPI) of Nicaragua in 1975 to that in 1992?
Offer a very short reply. 0.53. What is the ratio of the General Parity Index (GPI) of Low income in 1976 to that in 1977?
Make the answer very short. 0.98. What is the ratio of the General Parity Index (GPI) in North America in 1976 to that in 1977?
Ensure brevity in your answer.  0.92. What is the ratio of the General Parity Index (GPI) of Honduras in 1976 to that in 1977?
Keep it short and to the point. 0.83. What is the ratio of the General Parity Index (GPI) of Nicaragua in 1976 to that in 1977?
Offer a very short reply. 0.87. What is the ratio of the General Parity Index (GPI) in Low income in 1976 to that in 1990?
Offer a very short reply. 0.85. What is the ratio of the General Parity Index (GPI) of North America in 1976 to that in 1990?
Make the answer very short. 0.68. What is the ratio of the General Parity Index (GPI) in Honduras in 1976 to that in 1990?
Your answer should be compact. 0.64. What is the ratio of the General Parity Index (GPI) of Nicaragua in 1976 to that in 1990?
Your response must be concise. 0.45. What is the ratio of the General Parity Index (GPI) of Low income in 1976 to that in 1991?
Offer a very short reply. 0.85. What is the ratio of the General Parity Index (GPI) in North America in 1976 to that in 1991?
Provide a short and direct response. 0.67. What is the ratio of the General Parity Index (GPI) in Honduras in 1976 to that in 1991?
Provide a short and direct response. 0.62. What is the ratio of the General Parity Index (GPI) of Nicaragua in 1976 to that in 1991?
Offer a very short reply. 0.5. What is the ratio of the General Parity Index (GPI) of Low income in 1976 to that in 1992?
Give a very brief answer. 0.84. What is the ratio of the General Parity Index (GPI) in North America in 1976 to that in 1992?
Offer a very short reply. 0.67. What is the ratio of the General Parity Index (GPI) in Honduras in 1976 to that in 1992?
Keep it short and to the point. 0.65. What is the ratio of the General Parity Index (GPI) of Nicaragua in 1976 to that in 1992?
Make the answer very short. 0.48. What is the ratio of the General Parity Index (GPI) of Low income in 1977 to that in 1990?
Your answer should be compact. 0.87. What is the ratio of the General Parity Index (GPI) of North America in 1977 to that in 1990?
Your response must be concise. 0.74. What is the ratio of the General Parity Index (GPI) in Honduras in 1977 to that in 1990?
Provide a succinct answer. 0.77. What is the ratio of the General Parity Index (GPI) in Nicaragua in 1977 to that in 1990?
Your answer should be very brief. 0.51. What is the ratio of the General Parity Index (GPI) of Low income in 1977 to that in 1991?
Provide a succinct answer. 0.87. What is the ratio of the General Parity Index (GPI) of North America in 1977 to that in 1991?
Your answer should be compact. 0.73. What is the ratio of the General Parity Index (GPI) in Honduras in 1977 to that in 1991?
Offer a very short reply. 0.74. What is the ratio of the General Parity Index (GPI) of Nicaragua in 1977 to that in 1991?
Provide a succinct answer. 0.57. What is the ratio of the General Parity Index (GPI) of Low income in 1977 to that in 1992?
Provide a short and direct response. 0.86. What is the ratio of the General Parity Index (GPI) in North America in 1977 to that in 1992?
Offer a very short reply. 0.72. What is the ratio of the General Parity Index (GPI) in Honduras in 1977 to that in 1992?
Offer a very short reply. 0.78. What is the ratio of the General Parity Index (GPI) in Nicaragua in 1977 to that in 1992?
Ensure brevity in your answer.  0.55. What is the ratio of the General Parity Index (GPI) of North America in 1990 to that in 1991?
Keep it short and to the point. 0.99. What is the ratio of the General Parity Index (GPI) of Honduras in 1990 to that in 1991?
Your response must be concise. 0.96. What is the ratio of the General Parity Index (GPI) in Nicaragua in 1990 to that in 1991?
Ensure brevity in your answer.  1.11. What is the ratio of the General Parity Index (GPI) in Low income in 1990 to that in 1992?
Keep it short and to the point. 0.99. What is the ratio of the General Parity Index (GPI) in North America in 1990 to that in 1992?
Keep it short and to the point. 0.98. What is the ratio of the General Parity Index (GPI) of Nicaragua in 1990 to that in 1992?
Ensure brevity in your answer.  1.09. What is the ratio of the General Parity Index (GPI) of Low income in 1991 to that in 1992?
Your response must be concise. 0.98. What is the ratio of the General Parity Index (GPI) of Honduras in 1991 to that in 1992?
Your response must be concise. 1.05. What is the ratio of the General Parity Index (GPI) of Nicaragua in 1991 to that in 1992?
Provide a short and direct response. 0.98. What is the difference between the highest and the second highest General Parity Index (GPI) of Low income?
Your answer should be very brief. 0.01. What is the difference between the highest and the second highest General Parity Index (GPI) in North America?
Your response must be concise. 0.01. What is the difference between the highest and the second highest General Parity Index (GPI) of Honduras?
Keep it short and to the point. 0.03. What is the difference between the highest and the second highest General Parity Index (GPI) of Nicaragua?
Your answer should be compact. 0.09. What is the difference between the highest and the lowest General Parity Index (GPI) in Low income?
Make the answer very short. 0.11. What is the difference between the highest and the lowest General Parity Index (GPI) in North America?
Keep it short and to the point. 0.45. What is the difference between the highest and the lowest General Parity Index (GPI) in Honduras?
Make the answer very short. 0.3. What is the difference between the highest and the lowest General Parity Index (GPI) of Nicaragua?
Your answer should be very brief. 0.59. 